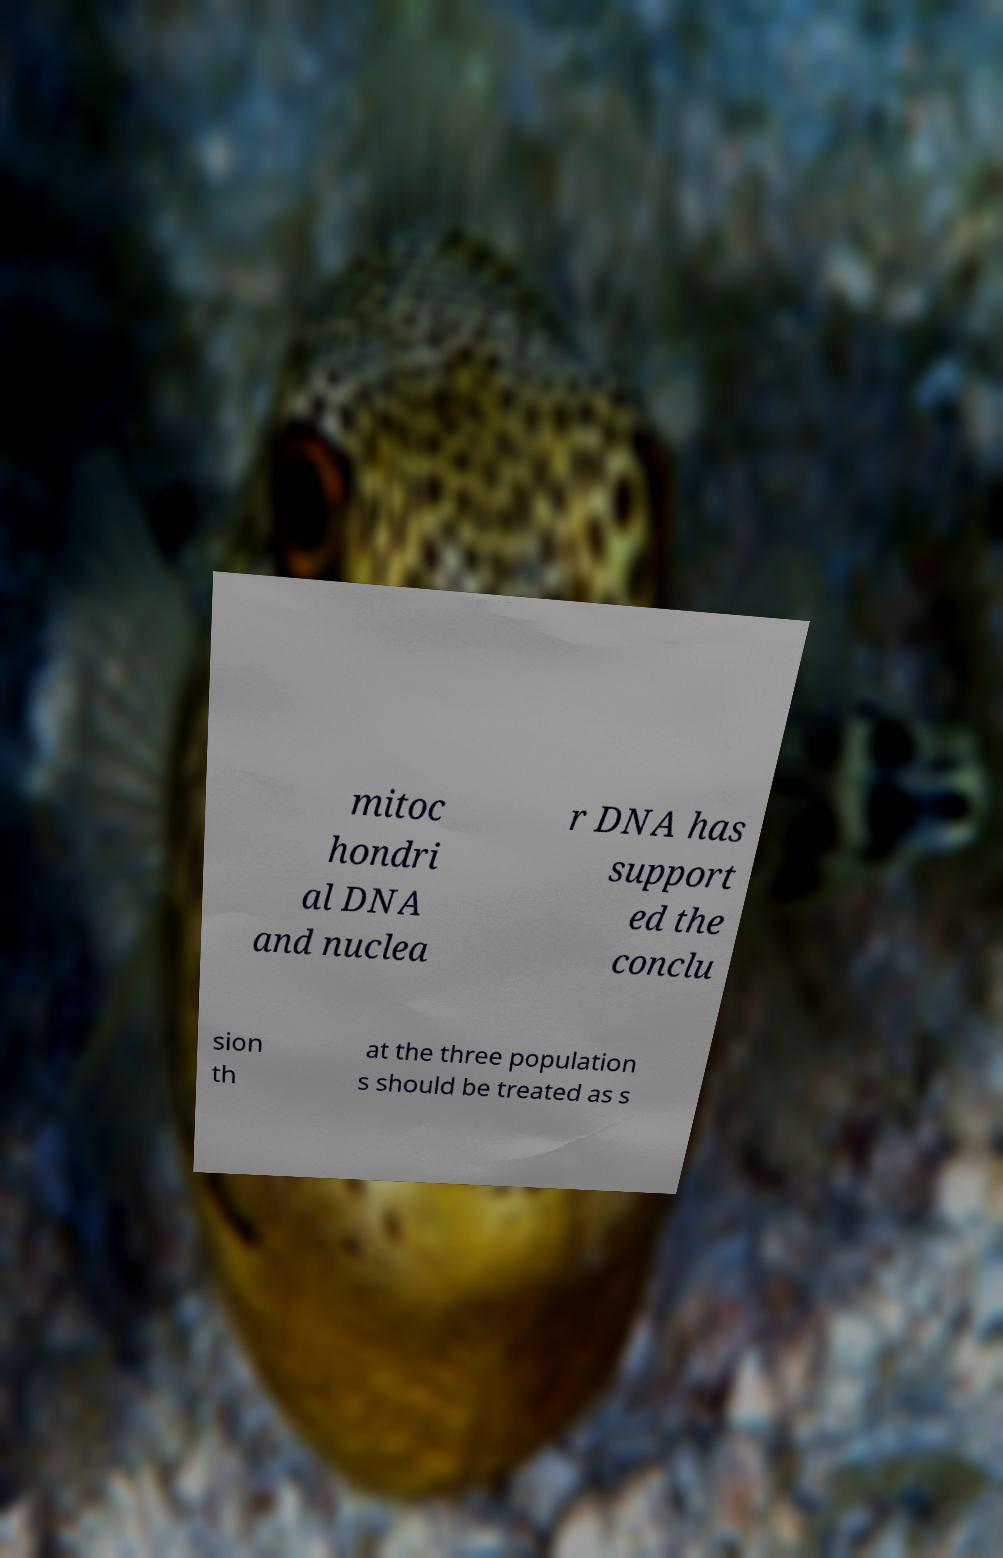Can you read and provide the text displayed in the image?This photo seems to have some interesting text. Can you extract and type it out for me? mitoc hondri al DNA and nuclea r DNA has support ed the conclu sion th at the three population s should be treated as s 